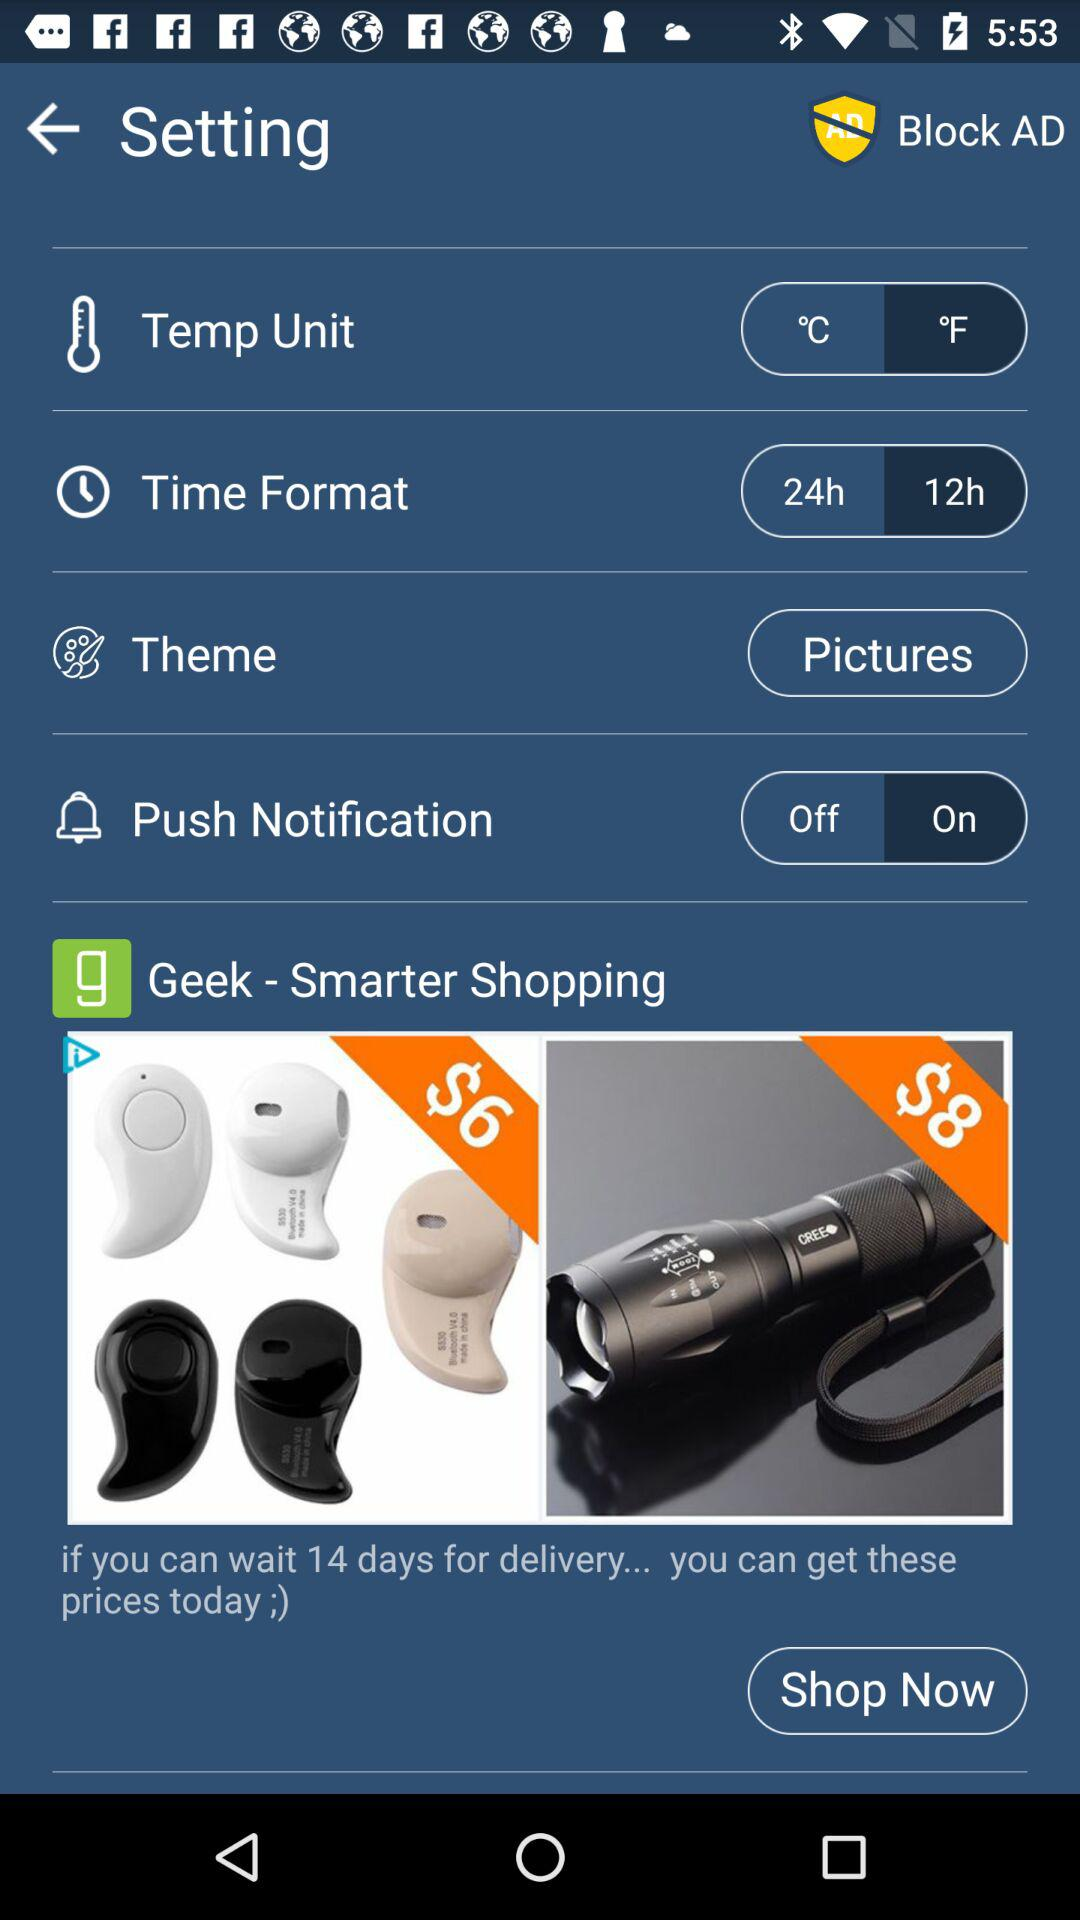What are the options available in "Time Format"? The available options are "24h" and "12h". 